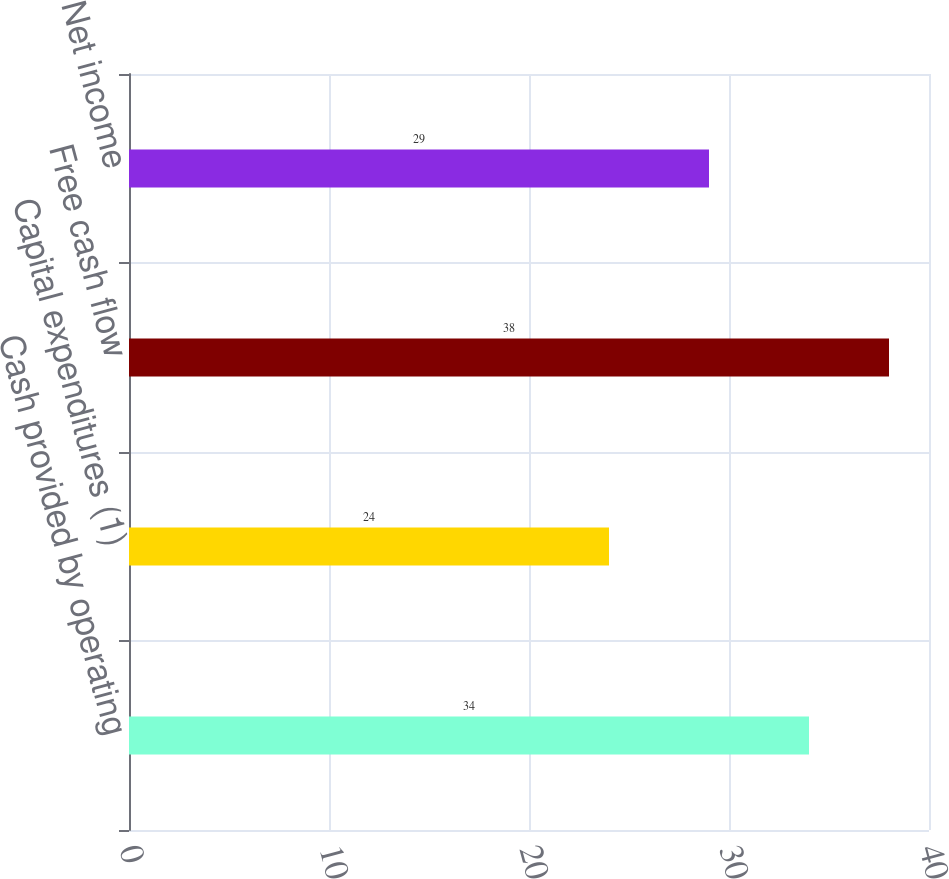<chart> <loc_0><loc_0><loc_500><loc_500><bar_chart><fcel>Cash provided by operating<fcel>Capital expenditures (1)<fcel>Free cash flow<fcel>Net income<nl><fcel>34<fcel>24<fcel>38<fcel>29<nl></chart> 